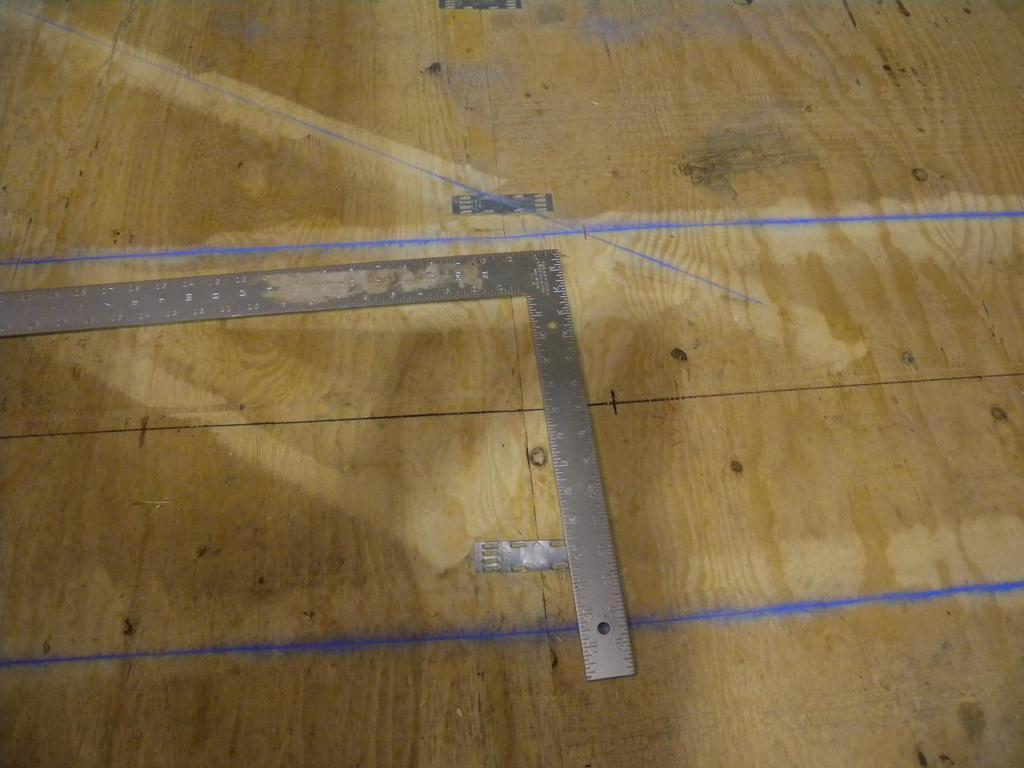What is the main object in the image? There is a measuring scale in the image. What is the measuring scale placed on? The measuring scale is on a wooden surface. Are there any other features on the wooden surface? Yes, there are margins on the wooden surface. What type of shirt is being twisted on the measuring scale in the image? There is no shirt present in the image, and the measuring scale is not being used to twist anything. 